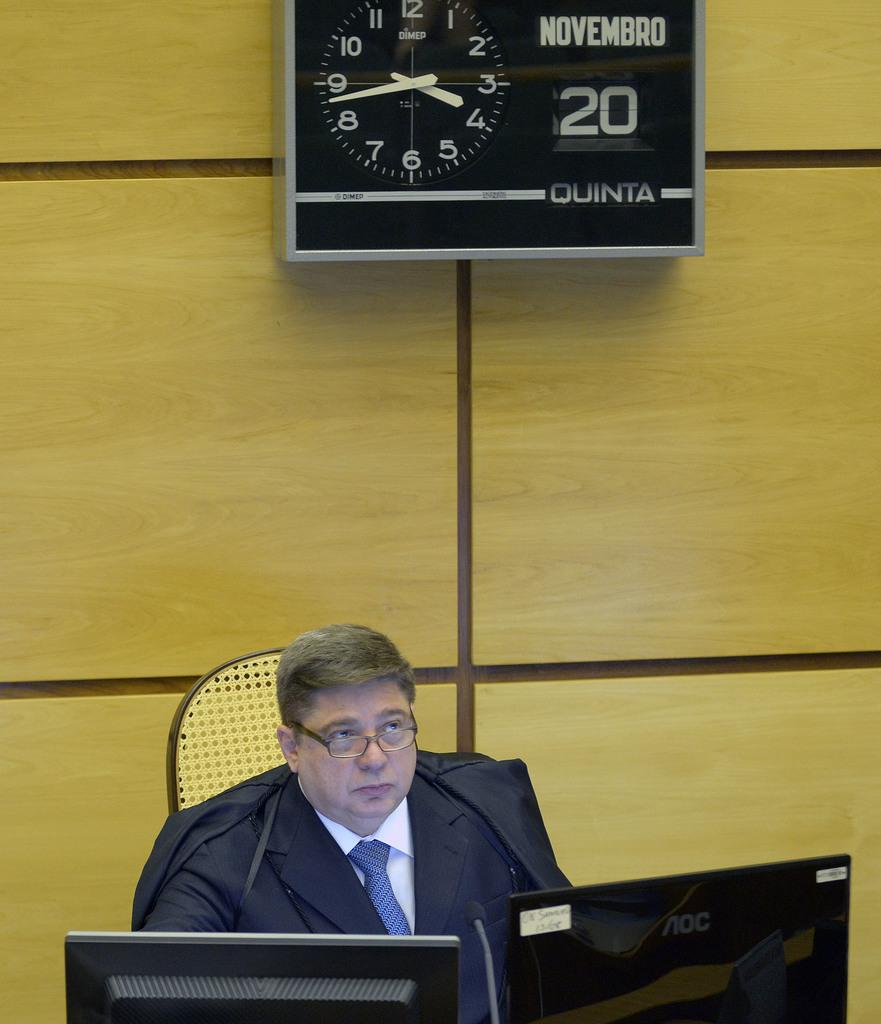<image>
Offer a succinct explanation of the picture presented. a man that is under a clock with the number 20 next to it 